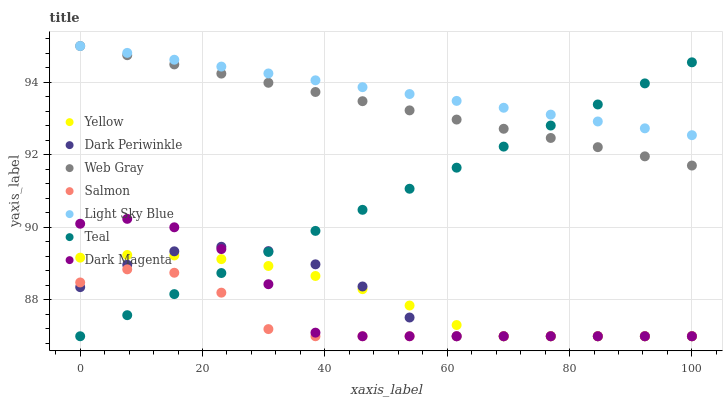Does Salmon have the minimum area under the curve?
Answer yes or no. Yes. Does Light Sky Blue have the maximum area under the curve?
Answer yes or no. Yes. Does Dark Magenta have the minimum area under the curve?
Answer yes or no. No. Does Dark Magenta have the maximum area under the curve?
Answer yes or no. No. Is Light Sky Blue the smoothest?
Answer yes or no. Yes. Is Dark Magenta the roughest?
Answer yes or no. Yes. Is Salmon the smoothest?
Answer yes or no. No. Is Salmon the roughest?
Answer yes or no. No. Does Dark Magenta have the lowest value?
Answer yes or no. Yes. Does Light Sky Blue have the lowest value?
Answer yes or no. No. Does Light Sky Blue have the highest value?
Answer yes or no. Yes. Does Dark Magenta have the highest value?
Answer yes or no. No. Is Yellow less than Web Gray?
Answer yes or no. Yes. Is Web Gray greater than Salmon?
Answer yes or no. Yes. Does Dark Magenta intersect Yellow?
Answer yes or no. Yes. Is Dark Magenta less than Yellow?
Answer yes or no. No. Is Dark Magenta greater than Yellow?
Answer yes or no. No. Does Yellow intersect Web Gray?
Answer yes or no. No. 